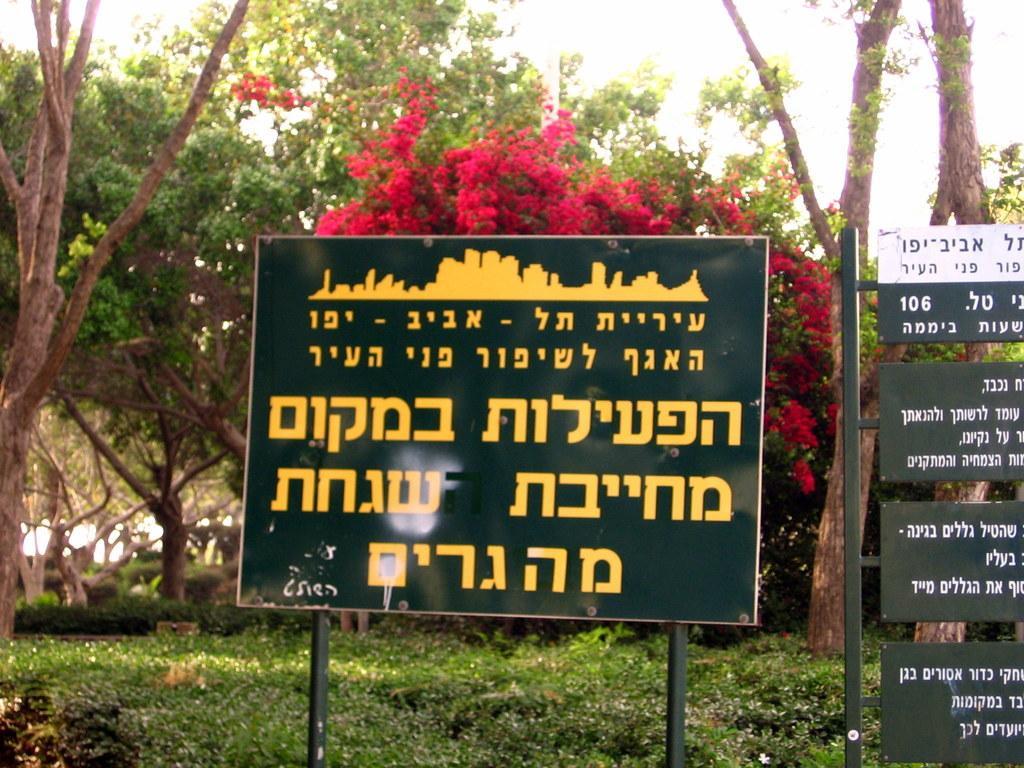Describe this image in one or two sentences. In this image I can see few green colour boards and on these boards I can see something is written. In the background I can see number of trees and here I can see red colour flowers. 